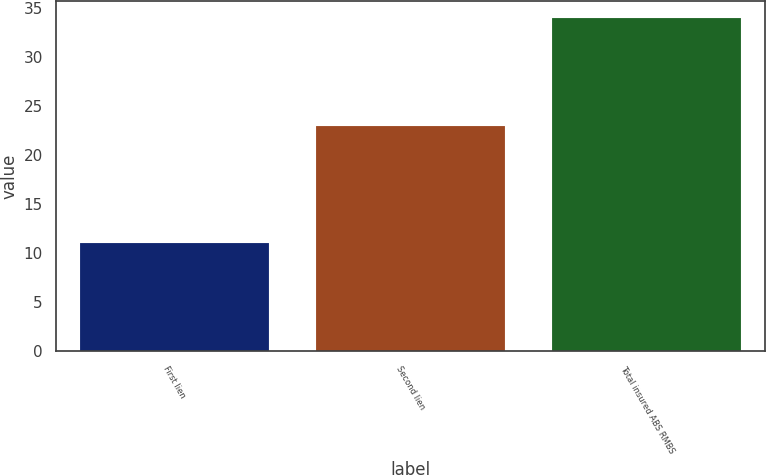Convert chart to OTSL. <chart><loc_0><loc_0><loc_500><loc_500><bar_chart><fcel>First lien<fcel>Second lien<fcel>Total insured ABS RMBS<nl><fcel>11<fcel>23<fcel>34<nl></chart> 